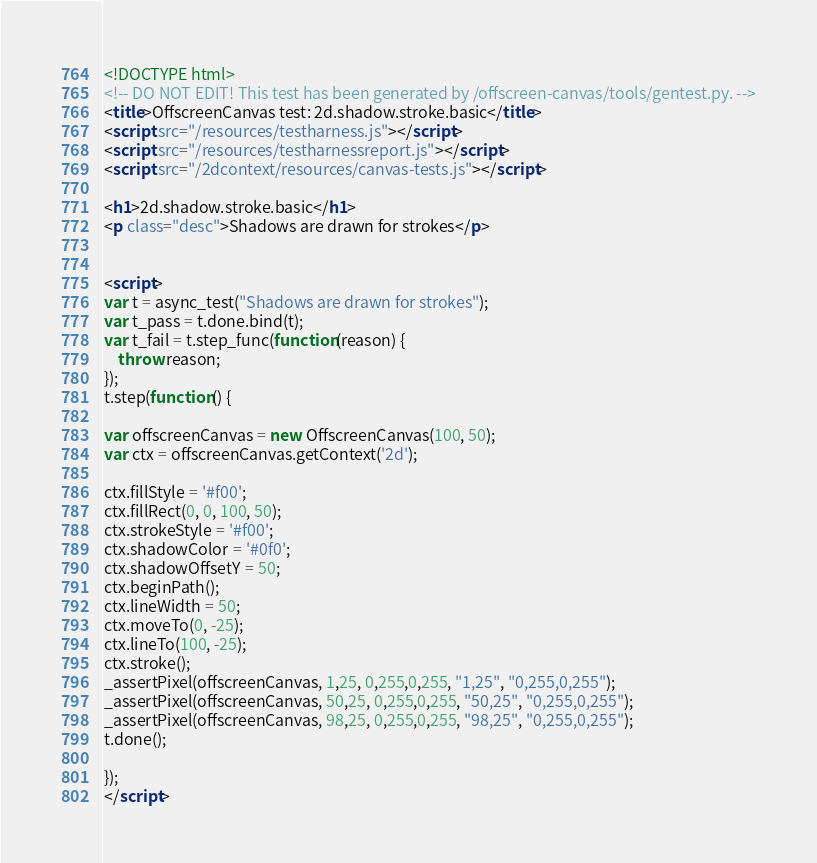<code> <loc_0><loc_0><loc_500><loc_500><_HTML_><!DOCTYPE html>
<!-- DO NOT EDIT! This test has been generated by /offscreen-canvas/tools/gentest.py. -->
<title>OffscreenCanvas test: 2d.shadow.stroke.basic</title>
<script src="/resources/testharness.js"></script>
<script src="/resources/testharnessreport.js"></script>
<script src="/2dcontext/resources/canvas-tests.js"></script>

<h1>2d.shadow.stroke.basic</h1>
<p class="desc">Shadows are drawn for strokes</p>


<script>
var t = async_test("Shadows are drawn for strokes");
var t_pass = t.done.bind(t);
var t_fail = t.step_func(function(reason) {
    throw reason;
});
t.step(function() {

var offscreenCanvas = new OffscreenCanvas(100, 50);
var ctx = offscreenCanvas.getContext('2d');

ctx.fillStyle = '#f00';
ctx.fillRect(0, 0, 100, 50);
ctx.strokeStyle = '#f00';
ctx.shadowColor = '#0f0';
ctx.shadowOffsetY = 50;
ctx.beginPath();
ctx.lineWidth = 50;
ctx.moveTo(0, -25);
ctx.lineTo(100, -25);
ctx.stroke();
_assertPixel(offscreenCanvas, 1,25, 0,255,0,255, "1,25", "0,255,0,255");
_assertPixel(offscreenCanvas, 50,25, 0,255,0,255, "50,25", "0,255,0,255");
_assertPixel(offscreenCanvas, 98,25, 0,255,0,255, "98,25", "0,255,0,255");
t.done();

});
</script>
</code> 